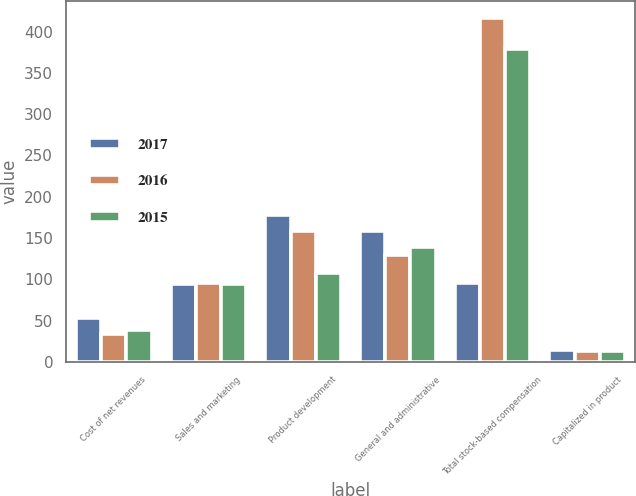<chart> <loc_0><loc_0><loc_500><loc_500><stacked_bar_chart><ecel><fcel>Cost of net revenues<fcel>Sales and marketing<fcel>Product development<fcel>General and administrative<fcel>Total stock-based compensation<fcel>Capitalized in product<nl><fcel>2017<fcel>53<fcel>94<fcel>178<fcel>158<fcel>95<fcel>14<nl><fcel>2016<fcel>34<fcel>95<fcel>158<fcel>129<fcel>416<fcel>13<nl><fcel>2015<fcel>38<fcel>94<fcel>108<fcel>139<fcel>379<fcel>13<nl></chart> 